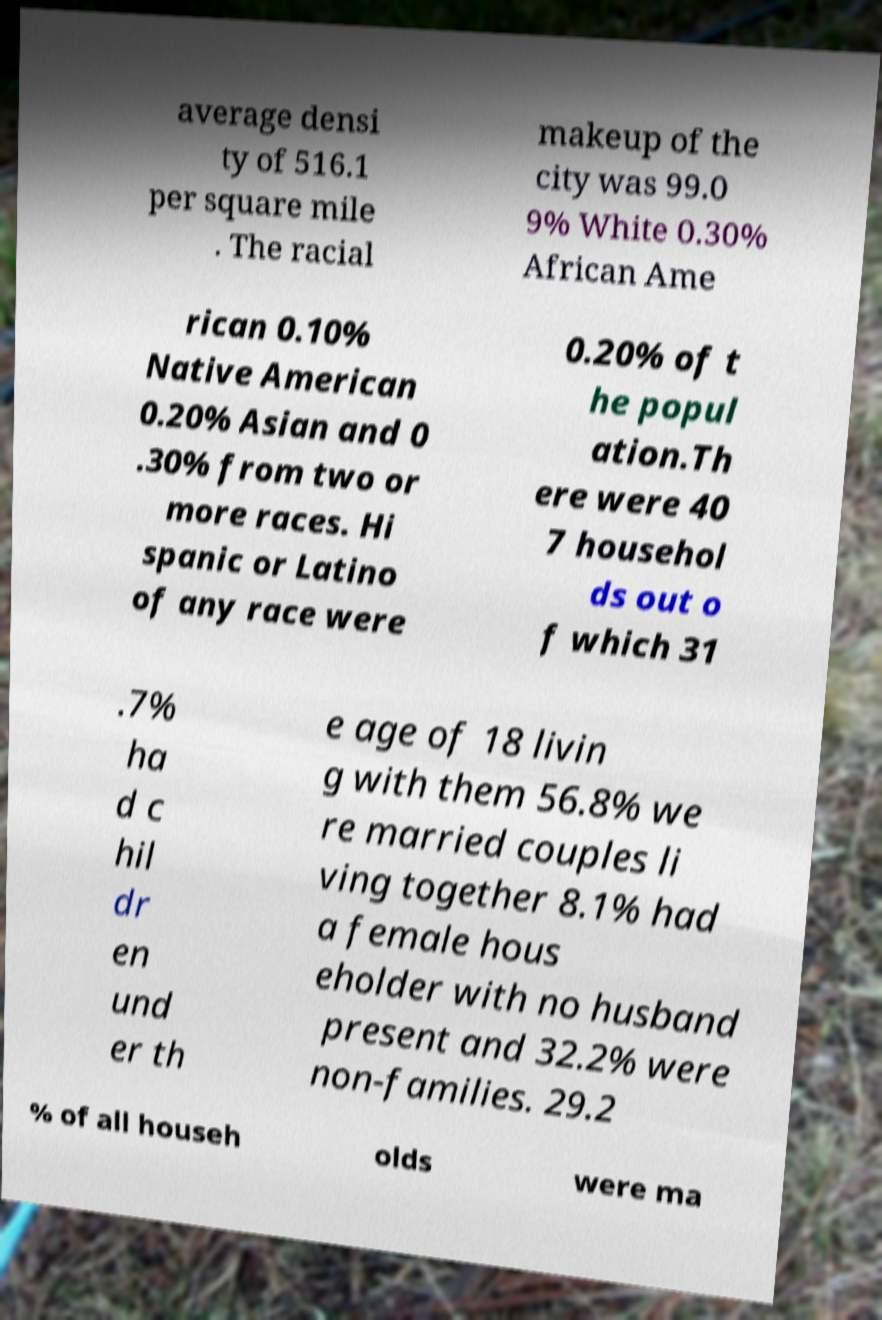Can you accurately transcribe the text from the provided image for me? average densi ty of 516.1 per square mile . The racial makeup of the city was 99.0 9% White 0.30% African Ame rican 0.10% Native American 0.20% Asian and 0 .30% from two or more races. Hi spanic or Latino of any race were 0.20% of t he popul ation.Th ere were 40 7 househol ds out o f which 31 .7% ha d c hil dr en und er th e age of 18 livin g with them 56.8% we re married couples li ving together 8.1% had a female hous eholder with no husband present and 32.2% were non-families. 29.2 % of all househ olds were ma 